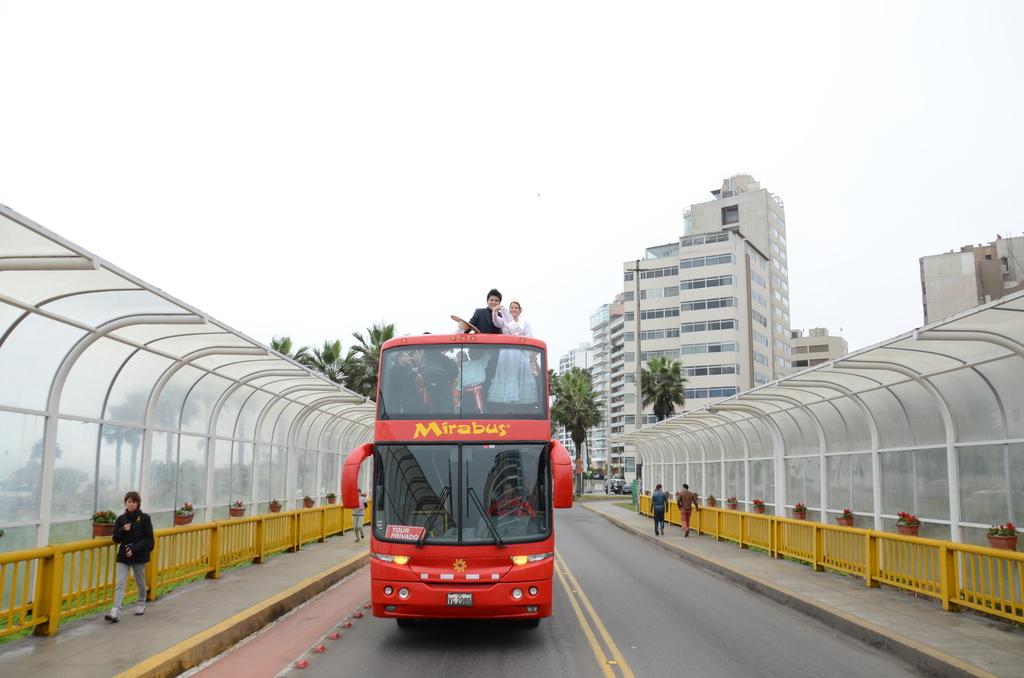What is the name of the bus?
Your answer should be very brief. Mirabus. What is the tag of this bus?
Your answer should be compact. Mirabus. 